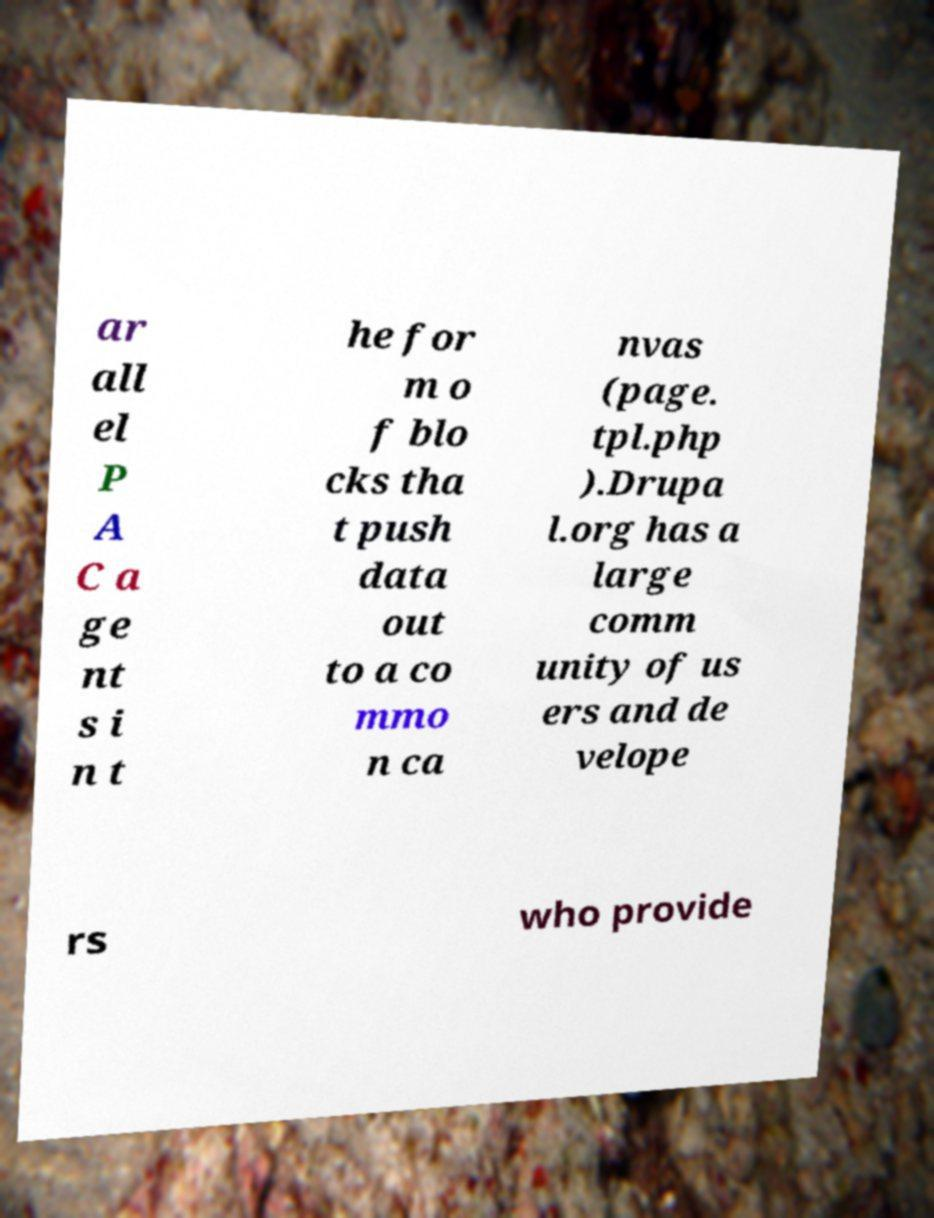Can you read and provide the text displayed in the image?This photo seems to have some interesting text. Can you extract and type it out for me? ar all el P A C a ge nt s i n t he for m o f blo cks tha t push data out to a co mmo n ca nvas (page. tpl.php ).Drupa l.org has a large comm unity of us ers and de velope rs who provide 